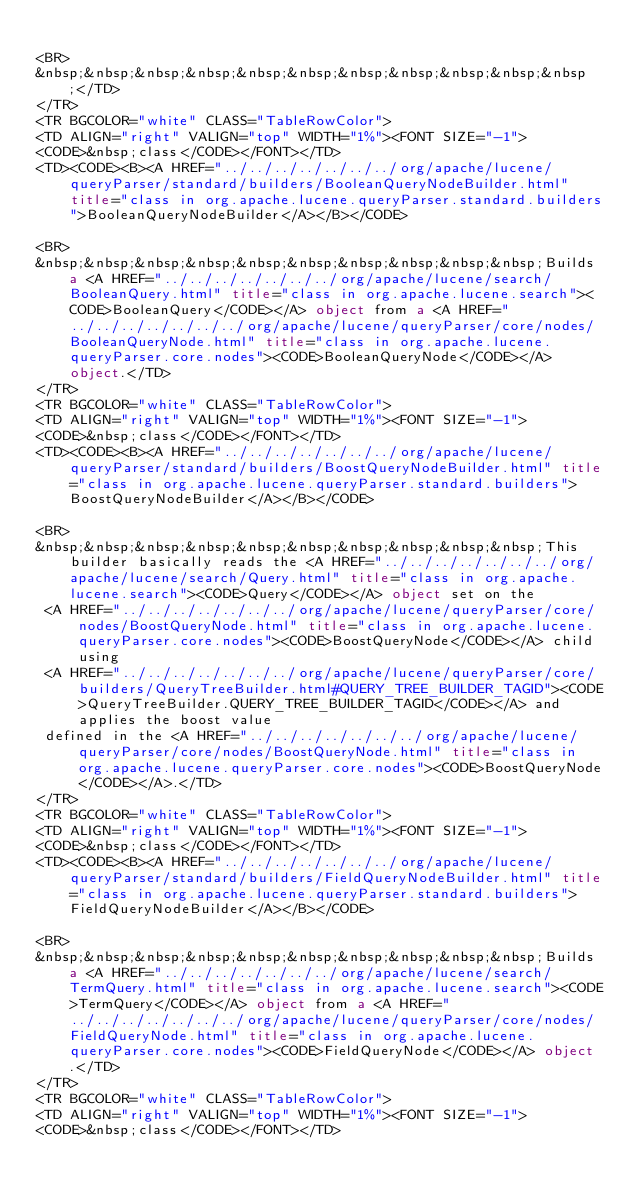<code> <loc_0><loc_0><loc_500><loc_500><_HTML_>
<BR>
&nbsp;&nbsp;&nbsp;&nbsp;&nbsp;&nbsp;&nbsp;&nbsp;&nbsp;&nbsp;&nbsp;</TD>
</TR>
<TR BGCOLOR="white" CLASS="TableRowColor">
<TD ALIGN="right" VALIGN="top" WIDTH="1%"><FONT SIZE="-1">
<CODE>&nbsp;class</CODE></FONT></TD>
<TD><CODE><B><A HREF="../../../../../../../org/apache/lucene/queryParser/standard/builders/BooleanQueryNodeBuilder.html" title="class in org.apache.lucene.queryParser.standard.builders">BooleanQueryNodeBuilder</A></B></CODE>

<BR>
&nbsp;&nbsp;&nbsp;&nbsp;&nbsp;&nbsp;&nbsp;&nbsp;&nbsp;&nbsp;Builds a <A HREF="../../../../../../../org/apache/lucene/search/BooleanQuery.html" title="class in org.apache.lucene.search"><CODE>BooleanQuery</CODE></A> object from a <A HREF="../../../../../../../org/apache/lucene/queryParser/core/nodes/BooleanQueryNode.html" title="class in org.apache.lucene.queryParser.core.nodes"><CODE>BooleanQueryNode</CODE></A> object.</TD>
</TR>
<TR BGCOLOR="white" CLASS="TableRowColor">
<TD ALIGN="right" VALIGN="top" WIDTH="1%"><FONT SIZE="-1">
<CODE>&nbsp;class</CODE></FONT></TD>
<TD><CODE><B><A HREF="../../../../../../../org/apache/lucene/queryParser/standard/builders/BoostQueryNodeBuilder.html" title="class in org.apache.lucene.queryParser.standard.builders">BoostQueryNodeBuilder</A></B></CODE>

<BR>
&nbsp;&nbsp;&nbsp;&nbsp;&nbsp;&nbsp;&nbsp;&nbsp;&nbsp;&nbsp;This builder basically reads the <A HREF="../../../../../../../org/apache/lucene/search/Query.html" title="class in org.apache.lucene.search"><CODE>Query</CODE></A> object set on the
 <A HREF="../../../../../../../org/apache/lucene/queryParser/core/nodes/BoostQueryNode.html" title="class in org.apache.lucene.queryParser.core.nodes"><CODE>BoostQueryNode</CODE></A> child using
 <A HREF="../../../../../../../org/apache/lucene/queryParser/core/builders/QueryTreeBuilder.html#QUERY_TREE_BUILDER_TAGID"><CODE>QueryTreeBuilder.QUERY_TREE_BUILDER_TAGID</CODE></A> and applies the boost value
 defined in the <A HREF="../../../../../../../org/apache/lucene/queryParser/core/nodes/BoostQueryNode.html" title="class in org.apache.lucene.queryParser.core.nodes"><CODE>BoostQueryNode</CODE></A>.</TD>
</TR>
<TR BGCOLOR="white" CLASS="TableRowColor">
<TD ALIGN="right" VALIGN="top" WIDTH="1%"><FONT SIZE="-1">
<CODE>&nbsp;class</CODE></FONT></TD>
<TD><CODE><B><A HREF="../../../../../../../org/apache/lucene/queryParser/standard/builders/FieldQueryNodeBuilder.html" title="class in org.apache.lucene.queryParser.standard.builders">FieldQueryNodeBuilder</A></B></CODE>

<BR>
&nbsp;&nbsp;&nbsp;&nbsp;&nbsp;&nbsp;&nbsp;&nbsp;&nbsp;&nbsp;Builds a <A HREF="../../../../../../../org/apache/lucene/search/TermQuery.html" title="class in org.apache.lucene.search"><CODE>TermQuery</CODE></A> object from a <A HREF="../../../../../../../org/apache/lucene/queryParser/core/nodes/FieldQueryNode.html" title="class in org.apache.lucene.queryParser.core.nodes"><CODE>FieldQueryNode</CODE></A> object.</TD>
</TR>
<TR BGCOLOR="white" CLASS="TableRowColor">
<TD ALIGN="right" VALIGN="top" WIDTH="1%"><FONT SIZE="-1">
<CODE>&nbsp;class</CODE></FONT></TD></code> 